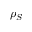<formula> <loc_0><loc_0><loc_500><loc_500>\rho _ { S }</formula> 